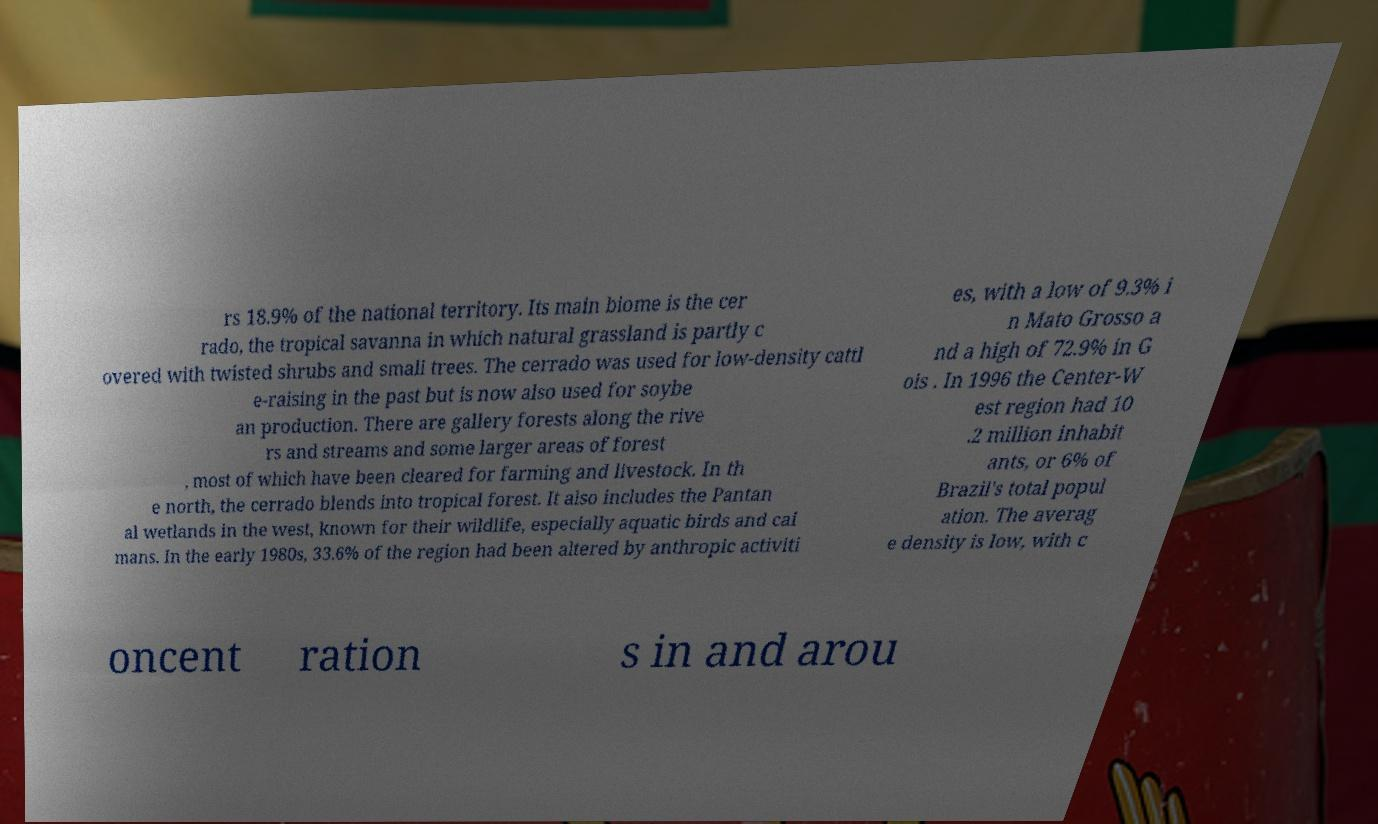For documentation purposes, I need the text within this image transcribed. Could you provide that? rs 18.9% of the national territory. Its main biome is the cer rado, the tropical savanna in which natural grassland is partly c overed with twisted shrubs and small trees. The cerrado was used for low-density cattl e-raising in the past but is now also used for soybe an production. There are gallery forests along the rive rs and streams and some larger areas of forest , most of which have been cleared for farming and livestock. In th e north, the cerrado blends into tropical forest. It also includes the Pantan al wetlands in the west, known for their wildlife, especially aquatic birds and cai mans. In the early 1980s, 33.6% of the region had been altered by anthropic activiti es, with a low of 9.3% i n Mato Grosso a nd a high of 72.9% in G ois . In 1996 the Center-W est region had 10 .2 million inhabit ants, or 6% of Brazil's total popul ation. The averag e density is low, with c oncent ration s in and arou 